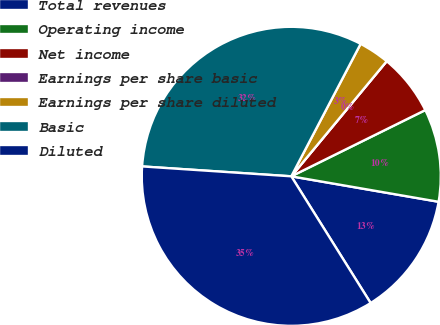Convert chart. <chart><loc_0><loc_0><loc_500><loc_500><pie_chart><fcel>Total revenues<fcel>Operating income<fcel>Net income<fcel>Earnings per share basic<fcel>Earnings per share diluted<fcel>Basic<fcel>Diluted<nl><fcel>13.37%<fcel>10.03%<fcel>6.68%<fcel>0.0%<fcel>3.34%<fcel>31.62%<fcel>34.96%<nl></chart> 